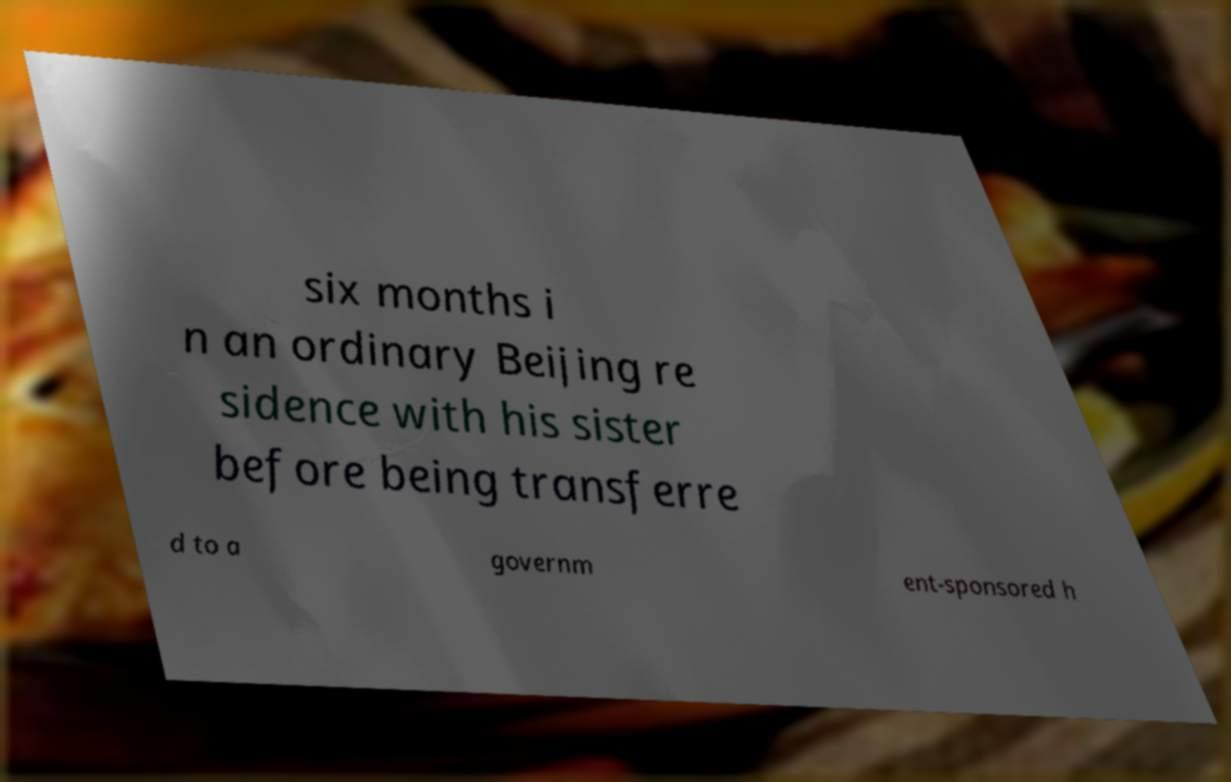There's text embedded in this image that I need extracted. Can you transcribe it verbatim? six months i n an ordinary Beijing re sidence with his sister before being transferre d to a governm ent-sponsored h 